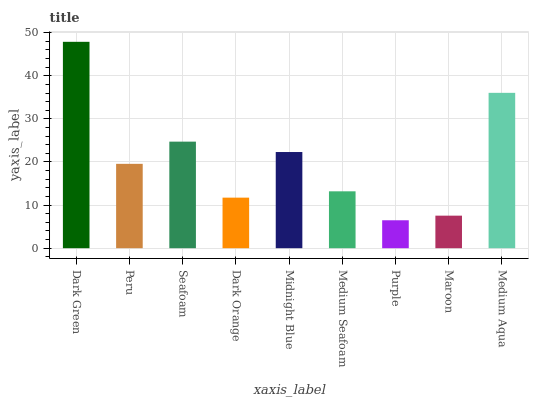Is Purple the minimum?
Answer yes or no. Yes. Is Dark Green the maximum?
Answer yes or no. Yes. Is Peru the minimum?
Answer yes or no. No. Is Peru the maximum?
Answer yes or no. No. Is Dark Green greater than Peru?
Answer yes or no. Yes. Is Peru less than Dark Green?
Answer yes or no. Yes. Is Peru greater than Dark Green?
Answer yes or no. No. Is Dark Green less than Peru?
Answer yes or no. No. Is Peru the high median?
Answer yes or no. Yes. Is Peru the low median?
Answer yes or no. Yes. Is Dark Orange the high median?
Answer yes or no. No. Is Medium Aqua the low median?
Answer yes or no. No. 